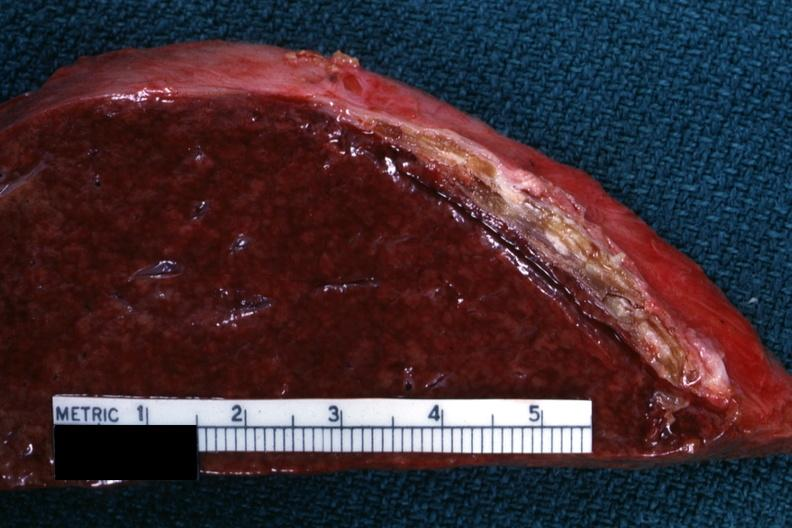what is present?
Answer the question using a single word or phrase. Spleen 